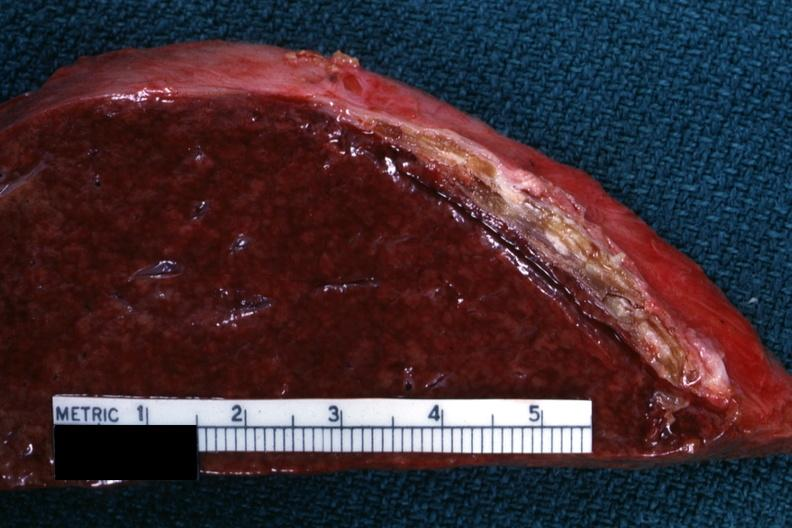what is present?
Answer the question using a single word or phrase. Spleen 